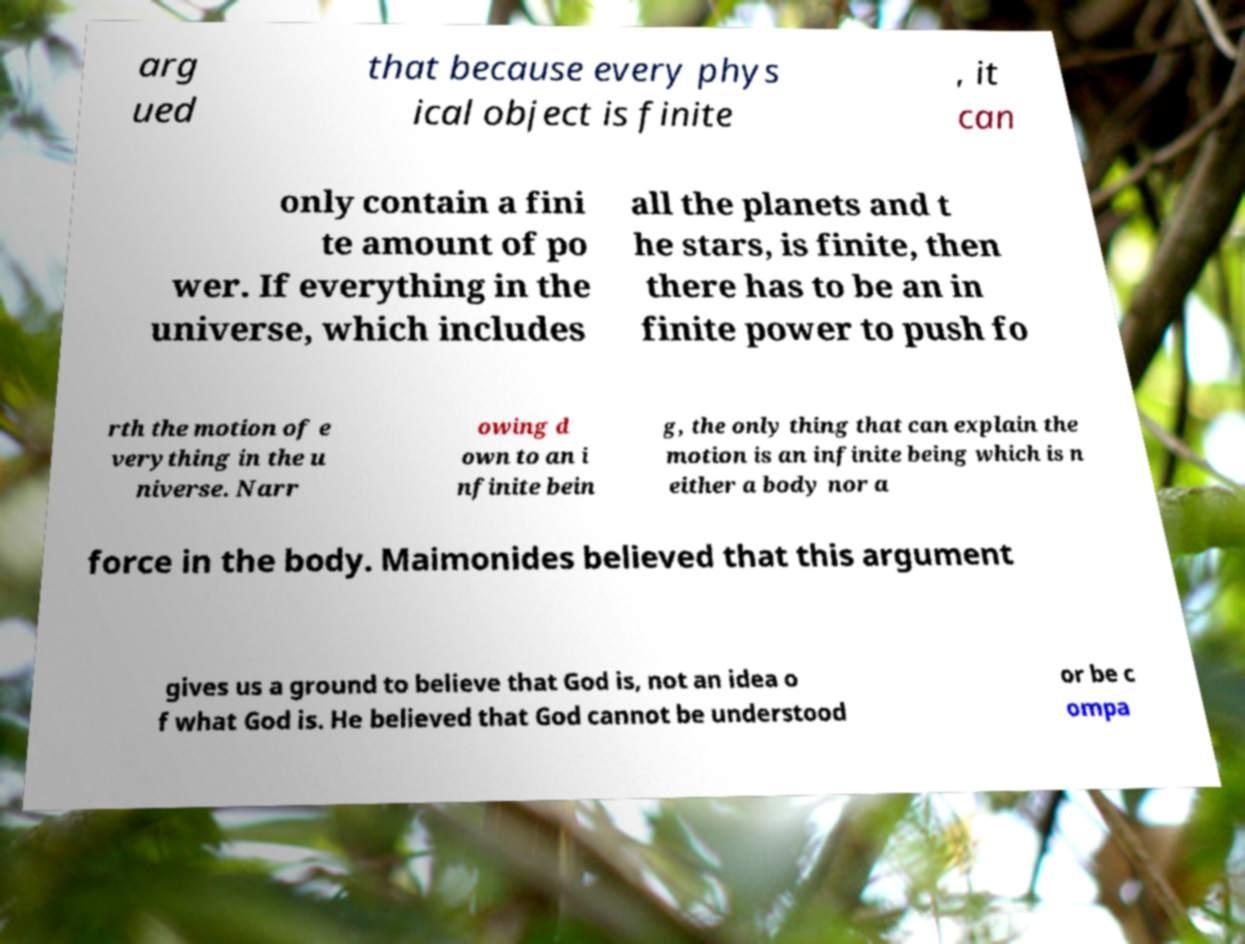I need the written content from this picture converted into text. Can you do that? arg ued that because every phys ical object is finite , it can only contain a fini te amount of po wer. If everything in the universe, which includes all the planets and t he stars, is finite, then there has to be an in finite power to push fo rth the motion of e verything in the u niverse. Narr owing d own to an i nfinite bein g, the only thing that can explain the motion is an infinite being which is n either a body nor a force in the body. Maimonides believed that this argument gives us a ground to believe that God is, not an idea o f what God is. He believed that God cannot be understood or be c ompa 